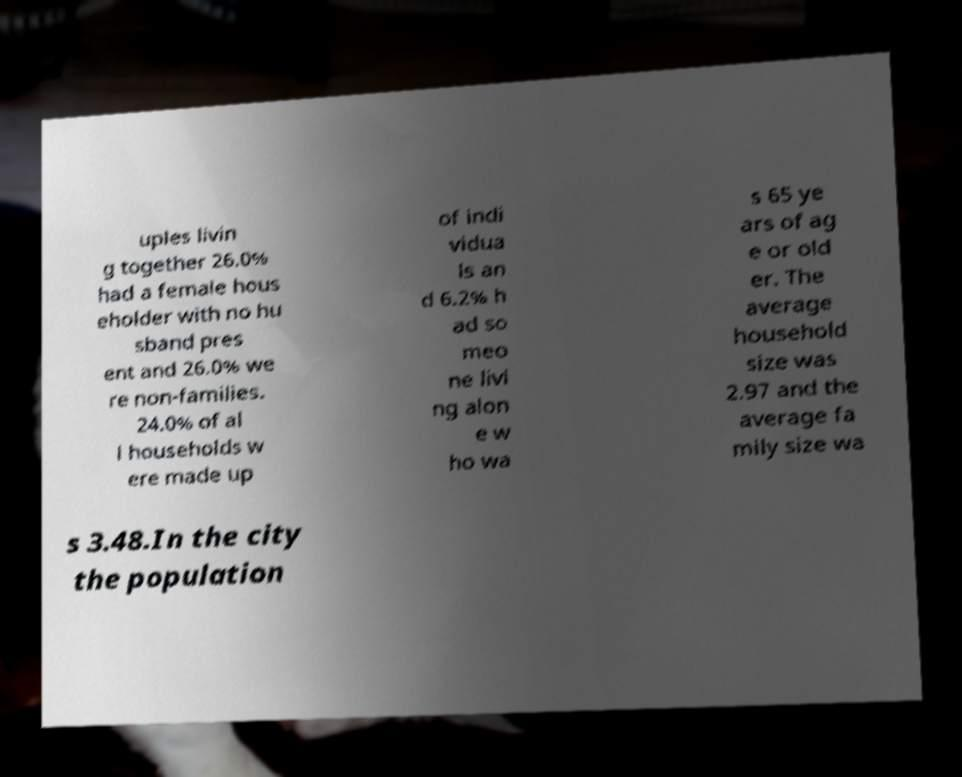Can you accurately transcribe the text from the provided image for me? uples livin g together 26.0% had a female hous eholder with no hu sband pres ent and 26.0% we re non-families. 24.0% of al l households w ere made up of indi vidua ls an d 6.2% h ad so meo ne livi ng alon e w ho wa s 65 ye ars of ag e or old er. The average household size was 2.97 and the average fa mily size wa s 3.48.In the city the population 